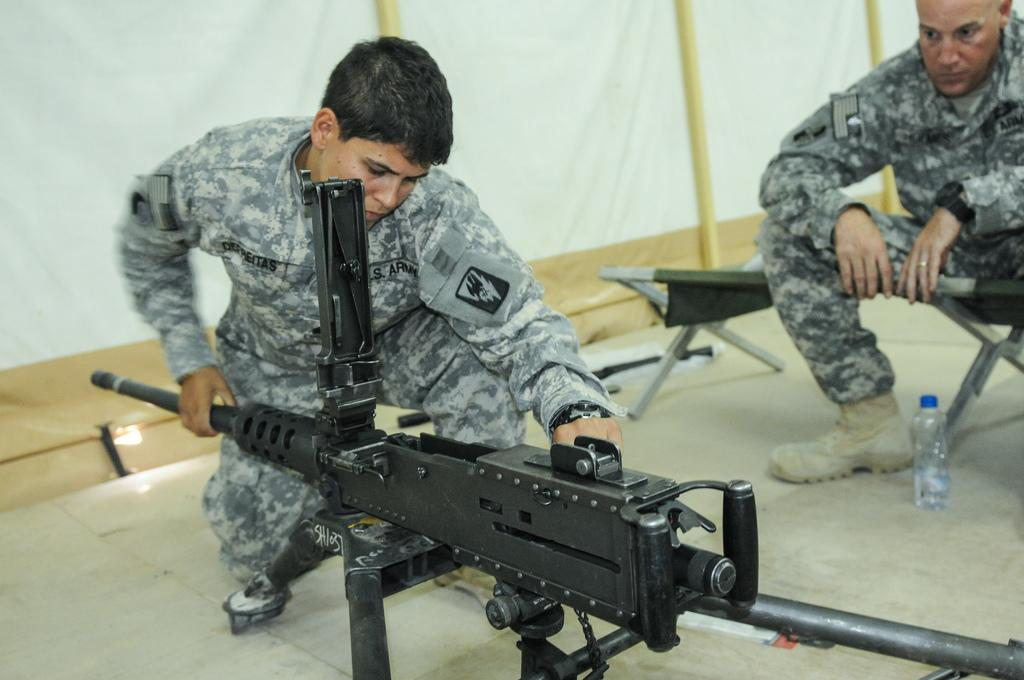How many people are in the image? There are two persons in the image. What is located in front of the persons? There is a machine and a bottle in front of the persons. What type of furniture is visible in the image? There is a table visible in the image. What can be seen at the back side of the persons? There is a white color fence visible at the back side of the persons. Can you see a zebra grazing near the persons in the image? No, there is no zebra present in the image. Are there any mountains visible in the background of the image? No, there are no mountains visible in the image. 